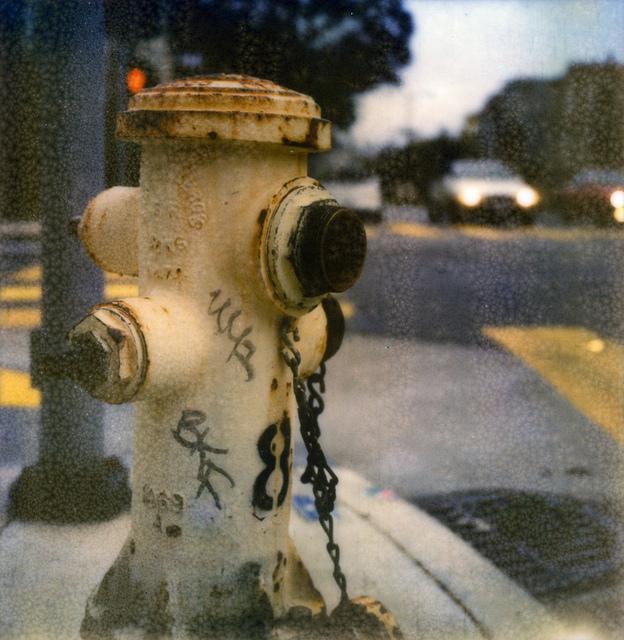How many cars are there?
Give a very brief answer. 2. How many giraffes are in the picture?
Give a very brief answer. 0. 